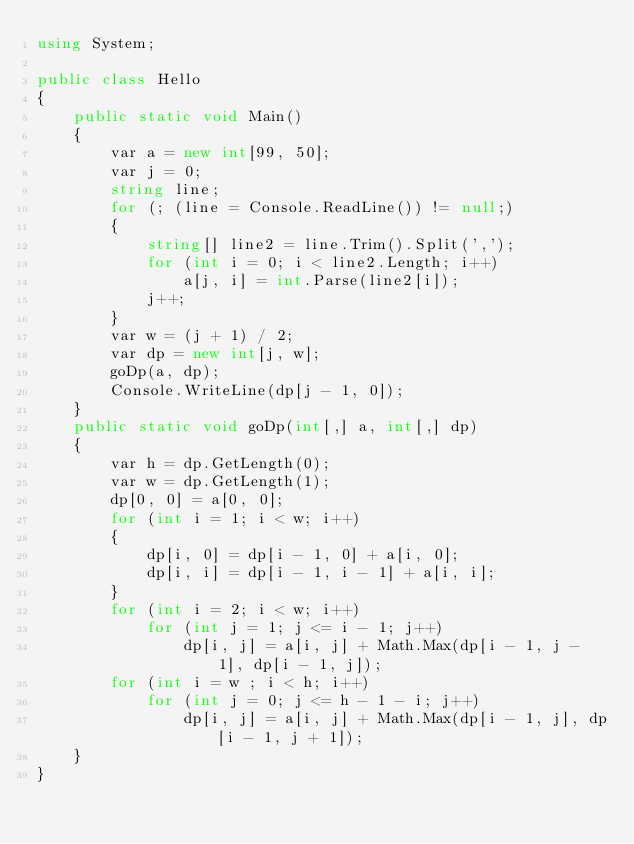Convert code to text. <code><loc_0><loc_0><loc_500><loc_500><_C#_>using System;

public class Hello
{
    public static void Main()
    {
        var a = new int[99, 50];
        var j = 0;
        string line;
        for (; (line = Console.ReadLine()) != null;)
        {
            string[] line2 = line.Trim().Split(',');
            for (int i = 0; i < line2.Length; i++)
                a[j, i] = int.Parse(line2[i]);
            j++;
        }
        var w = (j + 1) / 2;
        var dp = new int[j, w];
        goDp(a, dp);
        Console.WriteLine(dp[j - 1, 0]);
    }
    public static void goDp(int[,] a, int[,] dp)
    {
        var h = dp.GetLength(0);
        var w = dp.GetLength(1);
        dp[0, 0] = a[0, 0];
        for (int i = 1; i < w; i++)
        {
            dp[i, 0] = dp[i - 1, 0] + a[i, 0];
            dp[i, i] = dp[i - 1, i - 1] + a[i, i];
        }
        for (int i = 2; i < w; i++)
            for (int j = 1; j <= i - 1; j++)
                dp[i, j] = a[i, j] + Math.Max(dp[i - 1, j - 1], dp[i - 1, j]);
        for (int i = w ; i < h; i++)
            for (int j = 0; j <= h - 1 - i; j++)
                dp[i, j] = a[i, j] + Math.Max(dp[i - 1, j], dp[i - 1, j + 1]);
    }
}</code> 